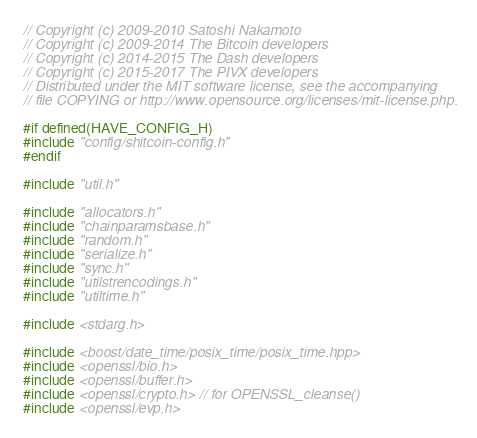<code> <loc_0><loc_0><loc_500><loc_500><_C++_>// Copyright (c) 2009-2010 Satoshi Nakamoto
// Copyright (c) 2009-2014 The Bitcoin developers
// Copyright (c) 2014-2015 The Dash developers
// Copyright (c) 2015-2017 The PIVX developers
// Distributed under the MIT software license, see the accompanying
// file COPYING or http://www.opensource.org/licenses/mit-license.php.

#if defined(HAVE_CONFIG_H)
#include "config/shitcoin-config.h"
#endif

#include "util.h"

#include "allocators.h"
#include "chainparamsbase.h"
#include "random.h"
#include "serialize.h"
#include "sync.h"
#include "utilstrencodings.h"
#include "utiltime.h"

#include <stdarg.h>

#include <boost/date_time/posix_time/posix_time.hpp>
#include <openssl/bio.h>
#include <openssl/buffer.h>
#include <openssl/crypto.h> // for OPENSSL_cleanse()
#include <openssl/evp.h>

</code> 